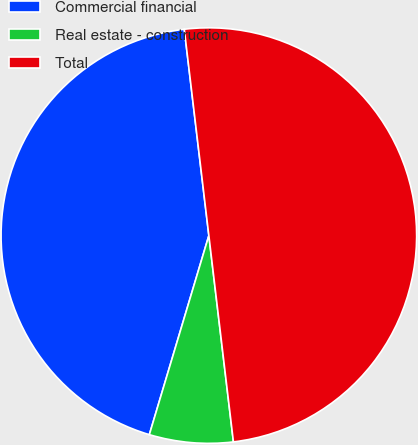Convert chart to OTSL. <chart><loc_0><loc_0><loc_500><loc_500><pie_chart><fcel>Commercial financial<fcel>Real estate - construction<fcel>Total<nl><fcel>43.49%<fcel>6.51%<fcel>50.0%<nl></chart> 